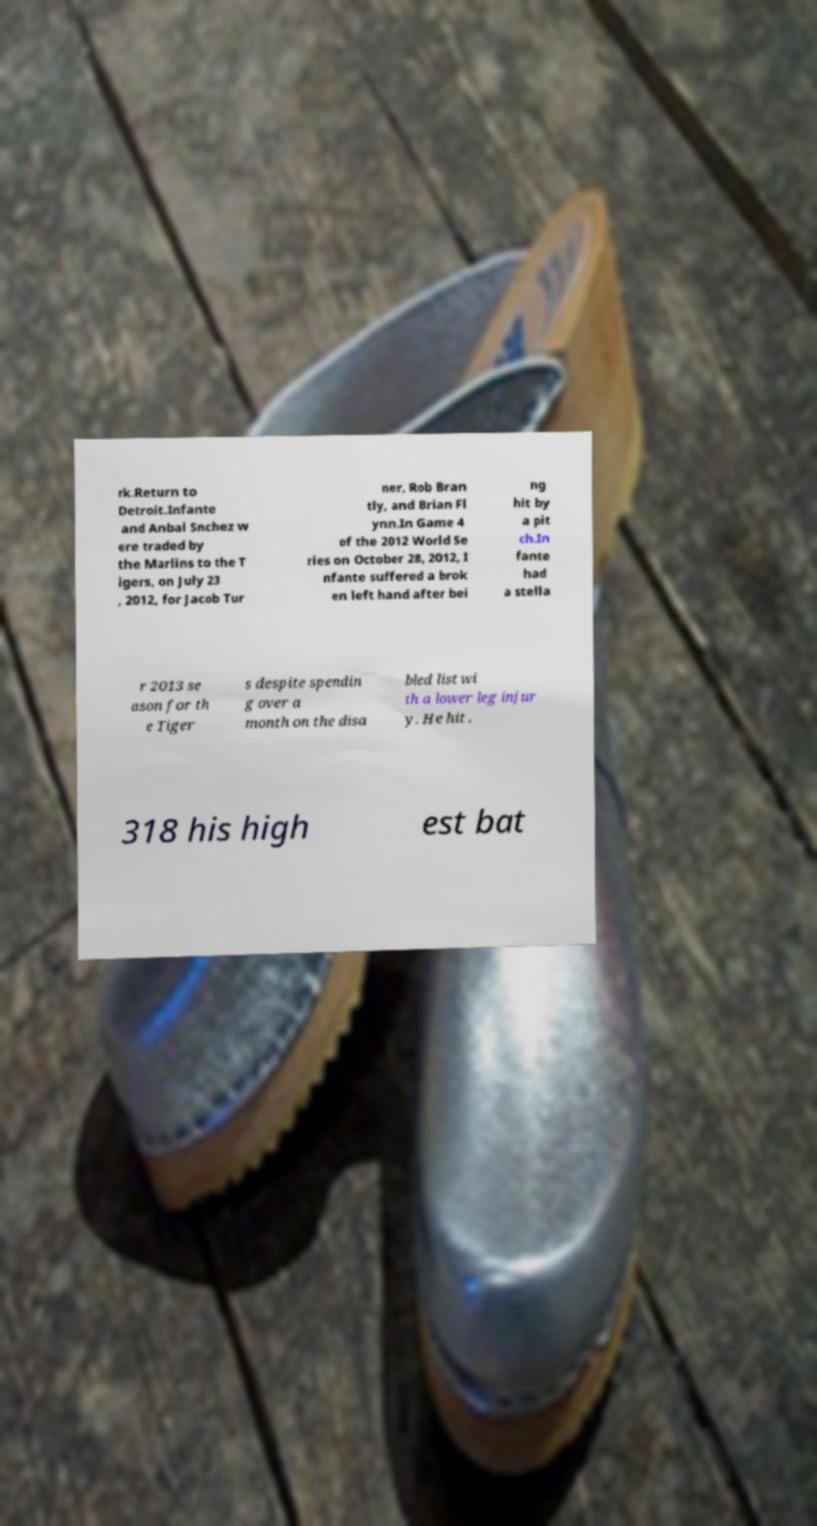Please identify and transcribe the text found in this image. rk.Return to Detroit.Infante and Anbal Snchez w ere traded by the Marlins to the T igers, on July 23 , 2012, for Jacob Tur ner, Rob Bran tly, and Brian Fl ynn.In Game 4 of the 2012 World Se ries on October 28, 2012, I nfante suffered a brok en left hand after bei ng hit by a pit ch.In fante had a stella r 2013 se ason for th e Tiger s despite spendin g over a month on the disa bled list wi th a lower leg injur y. He hit . 318 his high est bat 